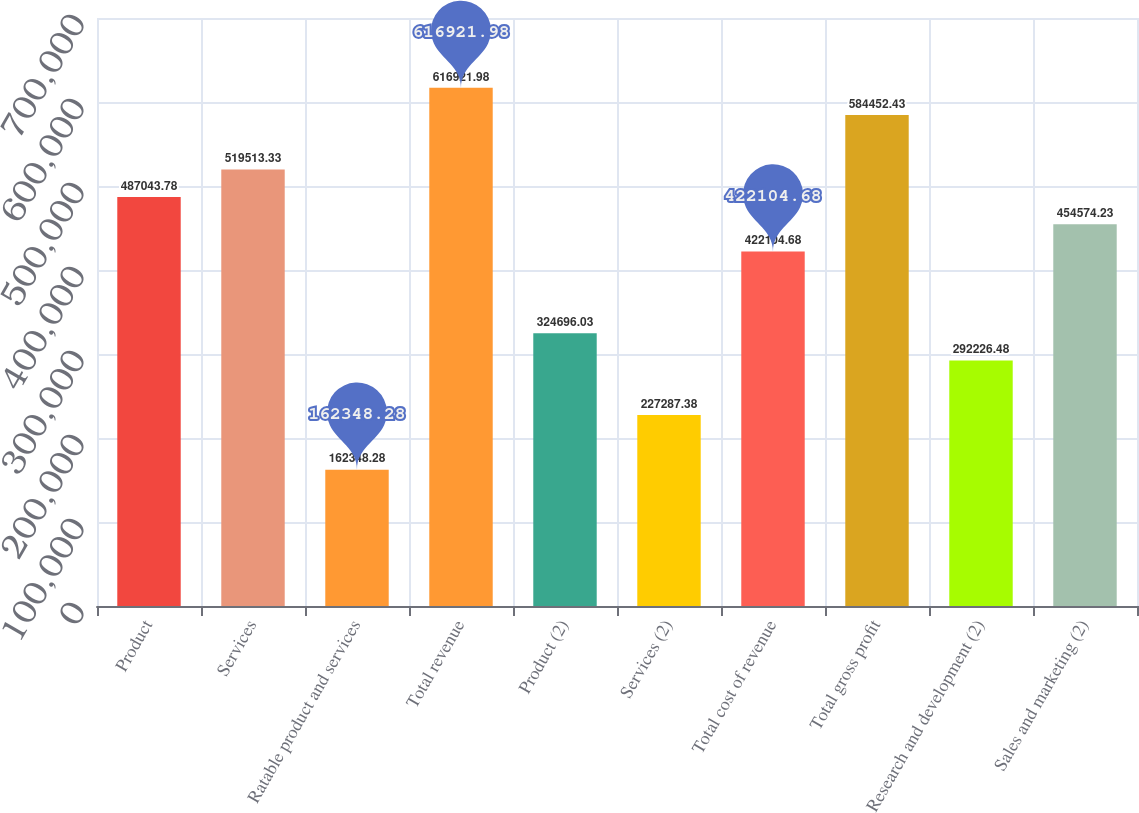Convert chart to OTSL. <chart><loc_0><loc_0><loc_500><loc_500><bar_chart><fcel>Product<fcel>Services<fcel>Ratable product and services<fcel>Total revenue<fcel>Product (2)<fcel>Services (2)<fcel>Total cost of revenue<fcel>Total gross profit<fcel>Research and development (2)<fcel>Sales and marketing (2)<nl><fcel>487044<fcel>519513<fcel>162348<fcel>616922<fcel>324696<fcel>227287<fcel>422105<fcel>584452<fcel>292226<fcel>454574<nl></chart> 